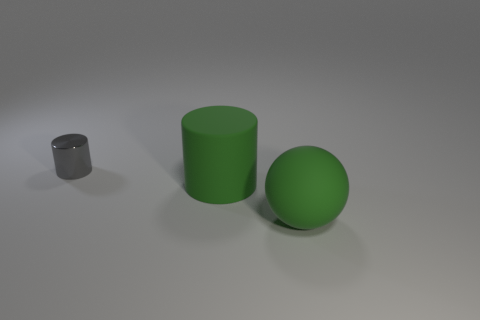Add 2 large green objects. How many objects exist? 5 Subtract 0 gray balls. How many objects are left? 3 Subtract all cylinders. How many objects are left? 1 Subtract 2 cylinders. How many cylinders are left? 0 Subtract all gray cylinders. Subtract all red spheres. How many cylinders are left? 1 Subtract all red cubes. How many green cylinders are left? 1 Subtract all gray things. Subtract all big matte things. How many objects are left? 0 Add 1 green rubber balls. How many green rubber balls are left? 2 Add 2 tiny red matte blocks. How many tiny red matte blocks exist? 2 Subtract all green cylinders. How many cylinders are left? 1 